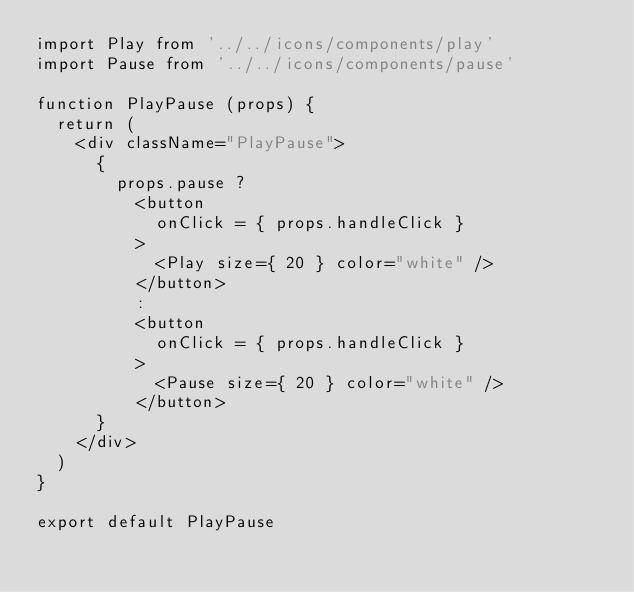<code> <loc_0><loc_0><loc_500><loc_500><_JavaScript_>import Play from '../../icons/components/play'
import Pause from '../../icons/components/pause'

function PlayPause (props) {
  return (
    <div className="PlayPause">
      {
        props.pause ?
          <button 
            onClick = { props.handleClick }
          >
            <Play size={ 20 } color="white" />
          </button>
          :
          <button
            onClick = { props.handleClick }
          >
            <Pause size={ 20 } color="white" />
          </button>
      }
    </div>
  )
}

export default PlayPause
</code> 